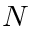<formula> <loc_0><loc_0><loc_500><loc_500>N</formula> 